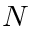<formula> <loc_0><loc_0><loc_500><loc_500>N</formula> 